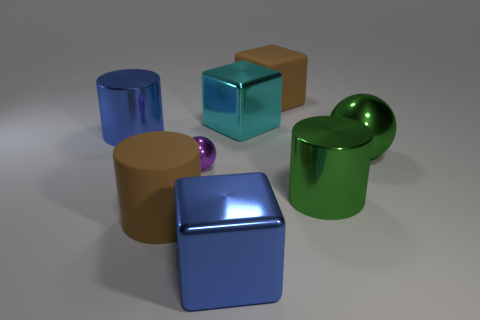Subtract all shiny cubes. How many cubes are left? 1 Subtract 1 blocks. How many blocks are left? 2 Add 2 red metal blocks. How many objects exist? 10 Subtract all green balls. How many balls are left? 1 Subtract all spheres. How many objects are left? 6 Subtract all yellow cubes. Subtract all purple spheres. How many cubes are left? 3 Subtract all green spheres. How many brown blocks are left? 1 Subtract all small cyan matte balls. Subtract all big green metal spheres. How many objects are left? 7 Add 8 brown rubber blocks. How many brown rubber blocks are left? 9 Add 3 large green balls. How many large green balls exist? 4 